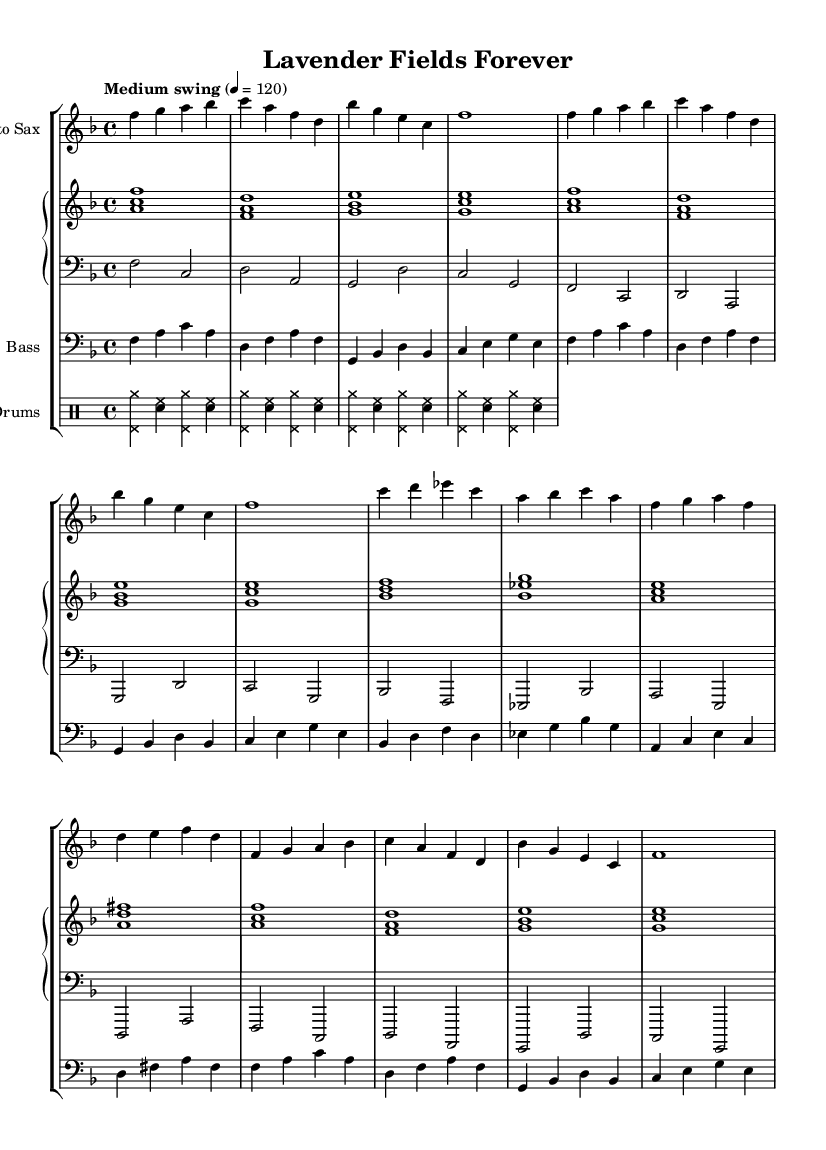What is the key signature of this music? The key signature can be found at the beginning of the sheet music. Here, it shows one flat (B flat), which identifies it as F major.
Answer: F major What is the time signature of this music? The time signature is indicated at the beginning of the sheet music. It shows "4/4," which means there are four beats in each measure, and the quarter note gets one beat.
Answer: 4/4 What is the tempo marking for this music? The tempo is indicated in the score with the marking "Medium swing" followed by a metronome marking of 120, which indicates the speed of the performance.
Answer: Medium swing 4 = 120 How many measures are in the A section? To determine the number of measures in the A section, we count the bars marked in the A part of the music. There are 4 measures in the A section.
Answer: 4 What instrument plays the melody in this piece? The melody is primarily played by the saxophone, as indicated by the "Alto Sax" labeling at the beginning of that staff.
Answer: Alto Sax What type of song structure is represented in this music? The song follows a common jazz structure with an AABA format. The section labeled A is repeated, followed by a contrasting section B, and then A is repeated again.
Answer: AABA What genre does this music belong to? The overall style of the music, indicated by the swing feel commonly associated with specific rhythms, as well as the instrumentation, identifies it as jazz.
Answer: Jazz 